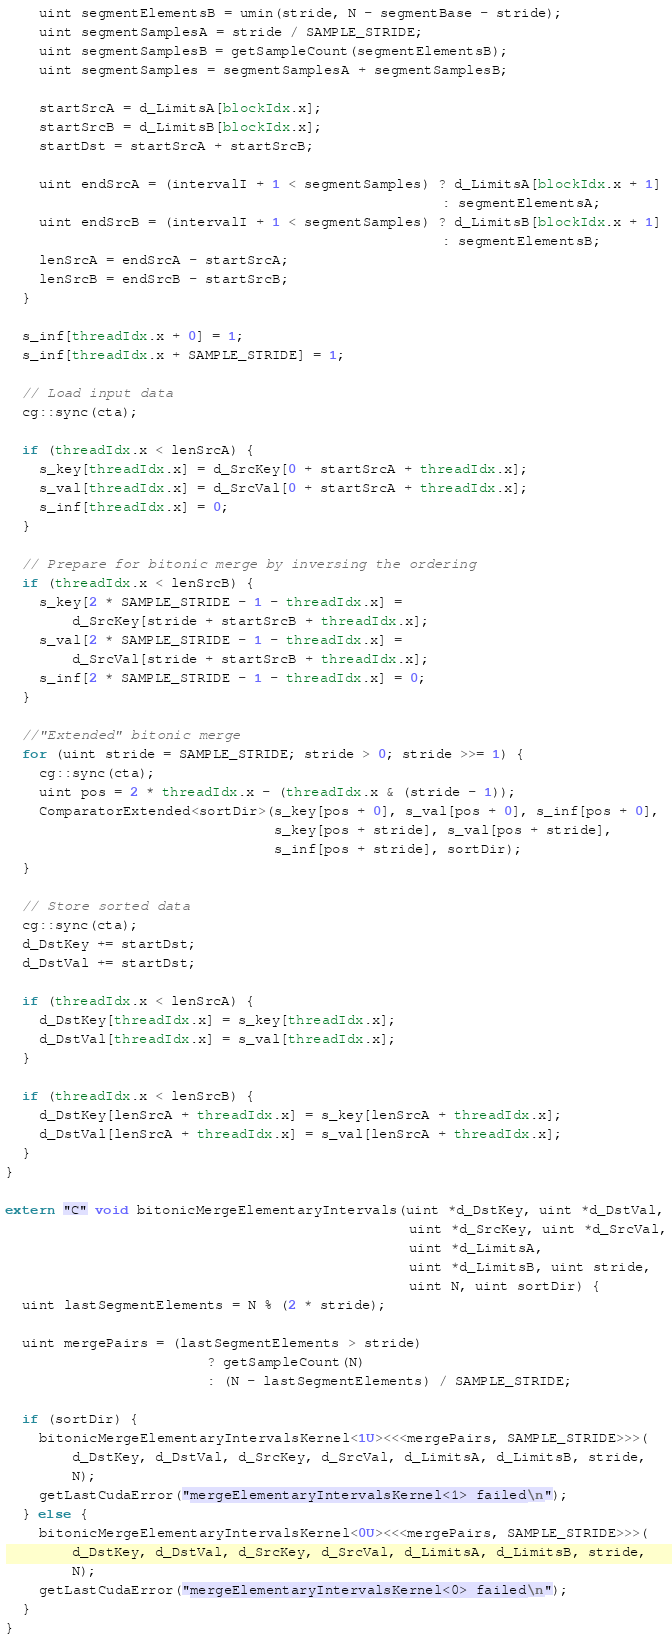<code> <loc_0><loc_0><loc_500><loc_500><_Cuda_>    uint segmentElementsB = umin(stride, N - segmentBase - stride);
    uint segmentSamplesA = stride / SAMPLE_STRIDE;
    uint segmentSamplesB = getSampleCount(segmentElementsB);
    uint segmentSamples = segmentSamplesA + segmentSamplesB;

    startSrcA = d_LimitsA[blockIdx.x];
    startSrcB = d_LimitsB[blockIdx.x];
    startDst = startSrcA + startSrcB;

    uint endSrcA = (intervalI + 1 < segmentSamples) ? d_LimitsA[blockIdx.x + 1]
                                                    : segmentElementsA;
    uint endSrcB = (intervalI + 1 < segmentSamples) ? d_LimitsB[blockIdx.x + 1]
                                                    : segmentElementsB;
    lenSrcA = endSrcA - startSrcA;
    lenSrcB = endSrcB - startSrcB;
  }

  s_inf[threadIdx.x + 0] = 1;
  s_inf[threadIdx.x + SAMPLE_STRIDE] = 1;

  // Load input data
  cg::sync(cta);

  if (threadIdx.x < lenSrcA) {
    s_key[threadIdx.x] = d_SrcKey[0 + startSrcA + threadIdx.x];
    s_val[threadIdx.x] = d_SrcVal[0 + startSrcA + threadIdx.x];
    s_inf[threadIdx.x] = 0;
  }

  // Prepare for bitonic merge by inversing the ordering
  if (threadIdx.x < lenSrcB) {
    s_key[2 * SAMPLE_STRIDE - 1 - threadIdx.x] =
        d_SrcKey[stride + startSrcB + threadIdx.x];
    s_val[2 * SAMPLE_STRIDE - 1 - threadIdx.x] =
        d_SrcVal[stride + startSrcB + threadIdx.x];
    s_inf[2 * SAMPLE_STRIDE - 1 - threadIdx.x] = 0;
  }

  //"Extended" bitonic merge
  for (uint stride = SAMPLE_STRIDE; stride > 0; stride >>= 1) {
    cg::sync(cta);
    uint pos = 2 * threadIdx.x - (threadIdx.x & (stride - 1));
    ComparatorExtended<sortDir>(s_key[pos + 0], s_val[pos + 0], s_inf[pos + 0],
                                s_key[pos + stride], s_val[pos + stride],
                                s_inf[pos + stride], sortDir);
  }

  // Store sorted data
  cg::sync(cta);
  d_DstKey += startDst;
  d_DstVal += startDst;

  if (threadIdx.x < lenSrcA) {
    d_DstKey[threadIdx.x] = s_key[threadIdx.x];
    d_DstVal[threadIdx.x] = s_val[threadIdx.x];
  }

  if (threadIdx.x < lenSrcB) {
    d_DstKey[lenSrcA + threadIdx.x] = s_key[lenSrcA + threadIdx.x];
    d_DstVal[lenSrcA + threadIdx.x] = s_val[lenSrcA + threadIdx.x];
  }
}

extern "C" void bitonicMergeElementaryIntervals(uint *d_DstKey, uint *d_DstVal,
                                                uint *d_SrcKey, uint *d_SrcVal,
                                                uint *d_LimitsA,
                                                uint *d_LimitsB, uint stride,
                                                uint N, uint sortDir) {
  uint lastSegmentElements = N % (2 * stride);

  uint mergePairs = (lastSegmentElements > stride)
                        ? getSampleCount(N)
                        : (N - lastSegmentElements) / SAMPLE_STRIDE;

  if (sortDir) {
    bitonicMergeElementaryIntervalsKernel<1U><<<mergePairs, SAMPLE_STRIDE>>>(
        d_DstKey, d_DstVal, d_SrcKey, d_SrcVal, d_LimitsA, d_LimitsB, stride,
        N);
    getLastCudaError("mergeElementaryIntervalsKernel<1> failed\n");
  } else {
    bitonicMergeElementaryIntervalsKernel<0U><<<mergePairs, SAMPLE_STRIDE>>>(
        d_DstKey, d_DstVal, d_SrcKey, d_SrcVal, d_LimitsA, d_LimitsB, stride,
        N);
    getLastCudaError("mergeElementaryIntervalsKernel<0> failed\n");
  }
}
</code> 